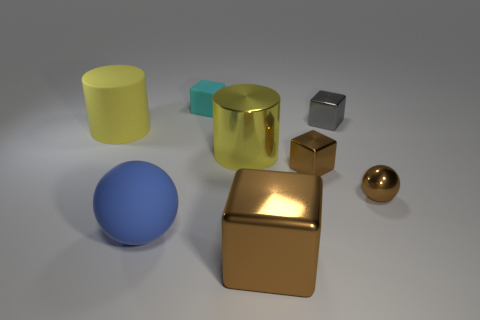Do the gray block and the large yellow cylinder that is to the left of the cyan block have the same material?
Ensure brevity in your answer.  No. What is the size of the ball that is on the right side of the small brown metallic block?
Ensure brevity in your answer.  Small. Is the number of rubber cylinders less than the number of gray rubber balls?
Your answer should be very brief. No. Are there any small metallic balls that have the same color as the big sphere?
Your response must be concise. No. There is a brown metal object that is on the left side of the metallic ball and behind the large blue thing; what is its shape?
Your answer should be compact. Cube. There is a yellow object that is left of the small thing left of the tiny brown shiny cube; what is its shape?
Offer a very short reply. Cylinder. Do the cyan matte object and the blue thing have the same shape?
Give a very brief answer. No. There is another cylinder that is the same color as the matte cylinder; what material is it?
Offer a terse response. Metal. Do the large cube and the rubber ball have the same color?
Provide a succinct answer. No. How many gray metallic blocks are to the left of the block that is in front of the big matte thing that is right of the yellow matte cylinder?
Offer a terse response. 0. 